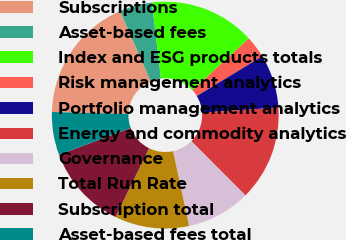Convert chart to OTSL. <chart><loc_0><loc_0><loc_500><loc_500><pie_chart><fcel>Subscriptions<fcel>Asset-based fees<fcel>Index and ESG products totals<fcel>Risk management analytics<fcel>Portfolio management analytics<fcel>Energy and commodity analytics<fcel>Governance<fcel>Total Run Rate<fcel>Subscription total<fcel>Asset-based fees total<nl><fcel>18.05%<fcel>4.63%<fcel>15.07%<fcel>3.14%<fcel>7.61%<fcel>13.58%<fcel>9.11%<fcel>10.6%<fcel>12.09%<fcel>6.12%<nl></chart> 